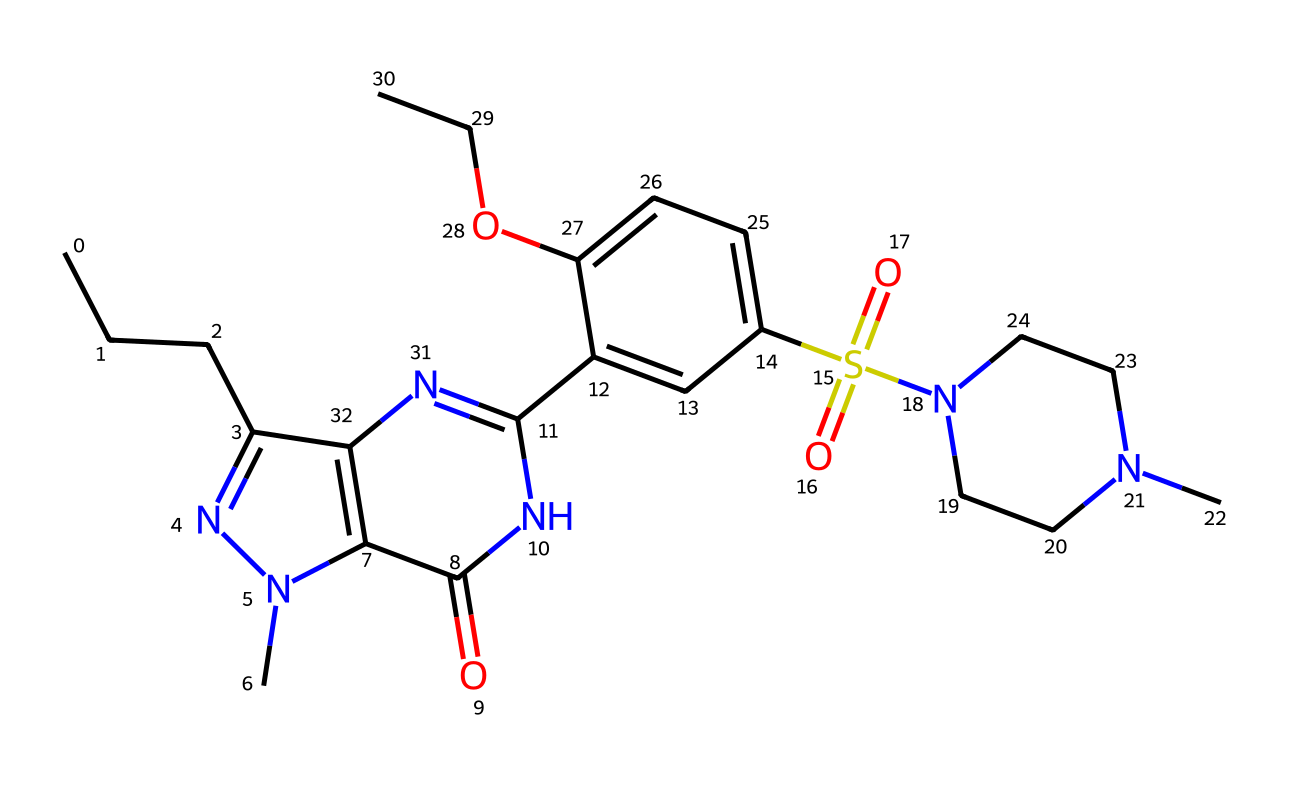What is the molecular formula of sildenafil? To determine the molecular formula from the SMILES representation, count the number of each type of atom in the structure. The SMILES indicates carbon (C), hydrogen (H), nitrogen (N), oxygen (O), and sulfur (S) atoms present in the compound, giving the formula C22H30N6O4S.
Answer: C22H30N6O4S How many nitrogen atoms are in sildenafil? The SMILES representation includes indications for nitrogen atoms, which can be visually counted or identified by the symbols 'n' and 'N'. There are six nitrogen atoms present in the structure.
Answer: 6 What functional groups are present in sildenafil? Identifying functional groups requires analyzing the structure for specific arrangements of atoms. In sildenafil, there are sulfonamide (S(=O)(=O)N) and amide (C(=O)N) groups identified from the SMILES notation.
Answer: sulfonamide and amide Which part of sildenafil is responsible for its pharmacological activity? Pharmacological activity typically arises from specific parts of the molecule that interact with biological targets. In sildenafil, the nitrogenous heterocyclic rings and the sulfonamide group are key in its mechanism of action related to inhibiting phosphodiesterase type 5 (PDE5).
Answer: nitrogenous heterocyclic rings and sulfonamide group How many rings are there in the sildenafil structure? The structure can be analyzed for cyclic components represented in the SMILES. There are three rings present in the chemical structure of sildenafil: two nitrogen-containing rings and one aromatic ring.
Answer: 3 What is the total number of carbon atoms in sildenafil? The total number of carbon atoms can be counted directly from the SMILES representation or identified through the 'C' symbols, showing a count of 22 carbon atoms.
Answer: 22 Which atom is part of a sulfonamide functional group in sildenafil? The sulfonamide group is denoted by the presence of sulfur (S) along with oxygen (O) in a specific arrangement. In sildenafil, the sulfur atom within the sulfonamide section, represented as S(=O)(=O)N, belongs to the functional group.
Answer: sulfur 